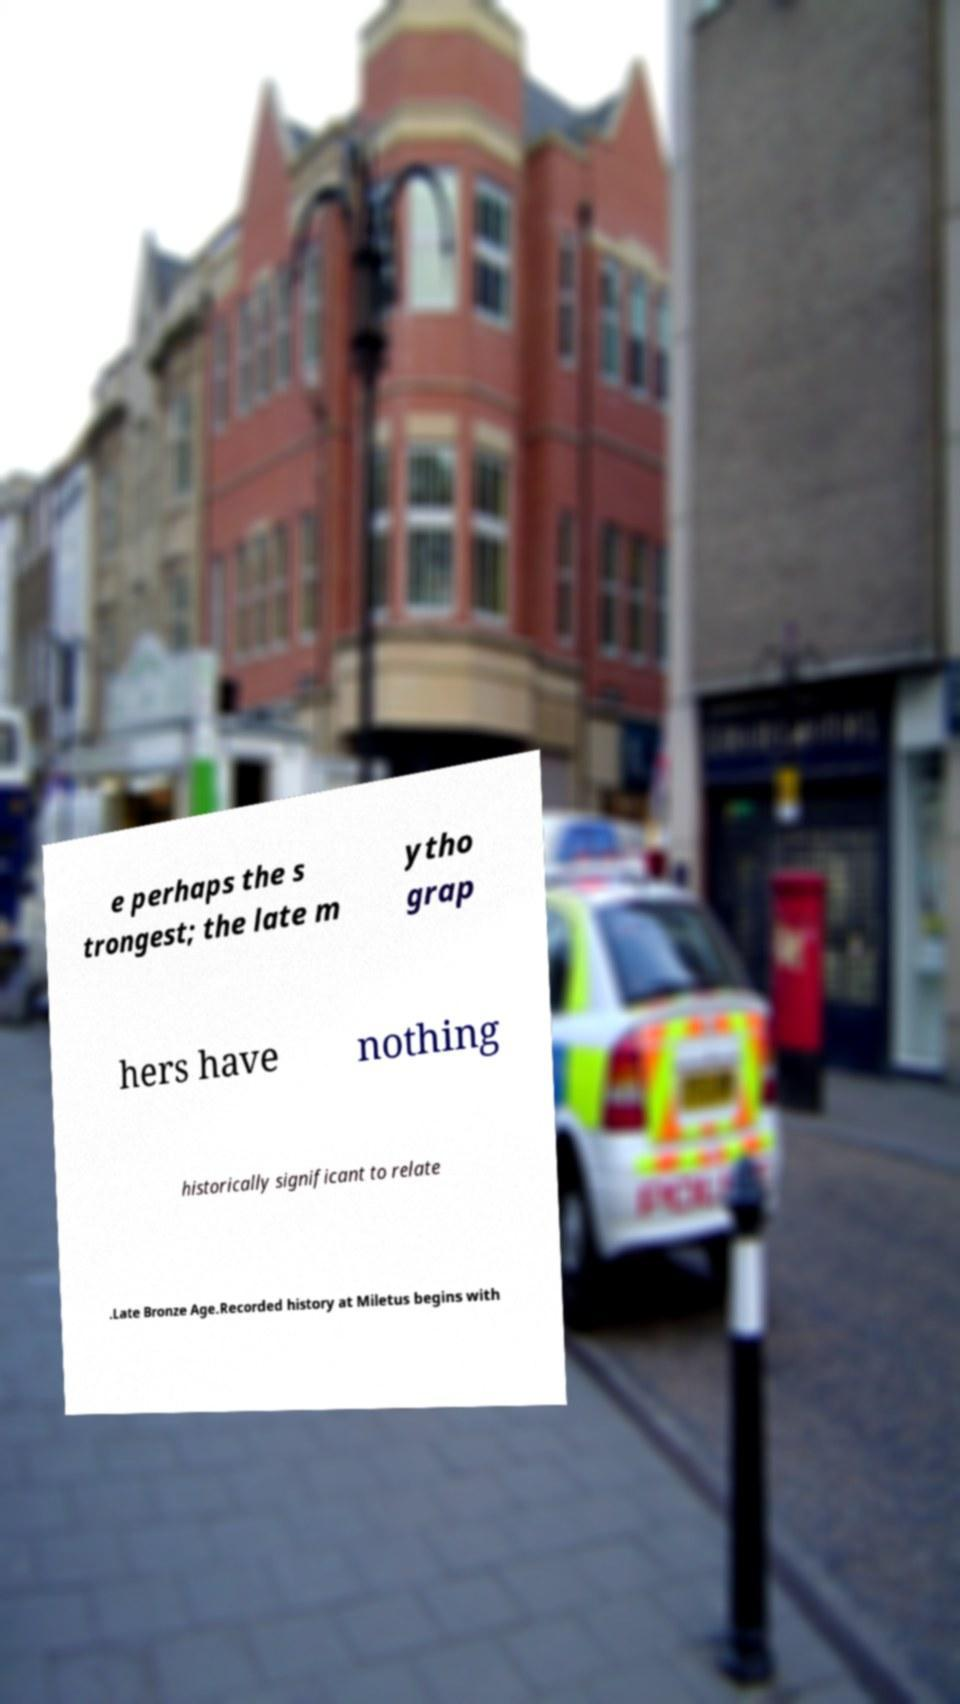Can you accurately transcribe the text from the provided image for me? e perhaps the s trongest; the late m ytho grap hers have nothing historically significant to relate .Late Bronze Age.Recorded history at Miletus begins with 